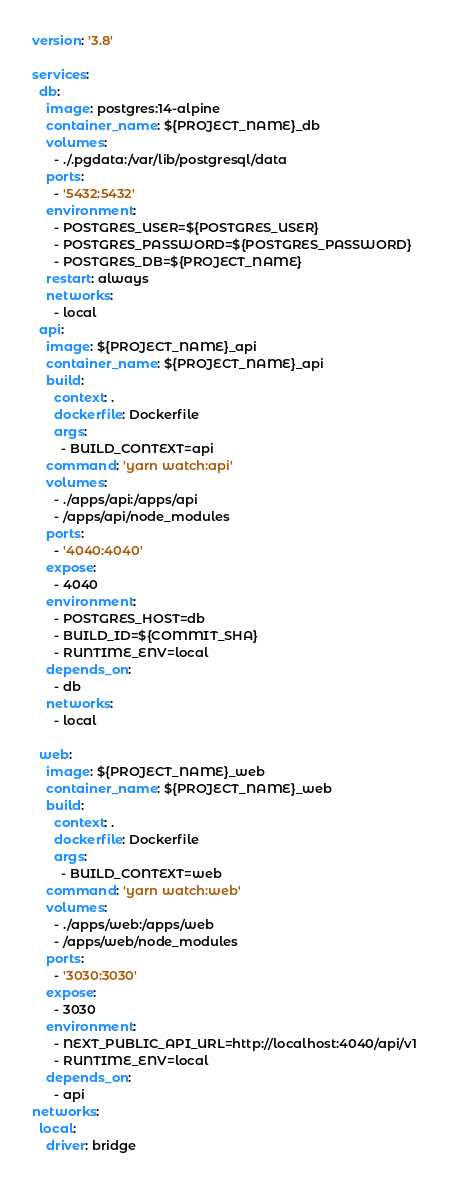Convert code to text. <code><loc_0><loc_0><loc_500><loc_500><_YAML_>version: '3.8'

services:
  db:
    image: postgres:14-alpine
    container_name: ${PROJECT_NAME}_db
    volumes:
      - ./.pgdata:/var/lib/postgresql/data
    ports:
      - '5432:5432'
    environment:
      - POSTGRES_USER=${POSTGRES_USER}
      - POSTGRES_PASSWORD=${POSTGRES_PASSWORD}
      - POSTGRES_DB=${PROJECT_NAME}
    restart: always
    networks:
      - local
  api:
    image: ${PROJECT_NAME}_api
    container_name: ${PROJECT_NAME}_api
    build:
      context: .
      dockerfile: Dockerfile
      args:
        - BUILD_CONTEXT=api
    command: 'yarn watch:api'
    volumes:
      - ./apps/api:/apps/api
      - /apps/api/node_modules
    ports:
      - '4040:4040'
    expose:
      - 4040
    environment:
      - POSTGRES_HOST=db
      - BUILD_ID=${COMMIT_SHA}
      - RUNTIME_ENV=local
    depends_on:
      - db
    networks:
      - local

  web:
    image: ${PROJECT_NAME}_web
    container_name: ${PROJECT_NAME}_web
    build:
      context: .
      dockerfile: Dockerfile
      args:
        - BUILD_CONTEXT=web
    command: 'yarn watch:web'
    volumes:
      - ./apps/web:/apps/web
      - /apps/web/node_modules
    ports:
      - '3030:3030'
    expose:
      - 3030
    environment:
      - NEXT_PUBLIC_API_URL=http://localhost:4040/api/v1
      - RUNTIME_ENV=local
    depends_on:
      - api
networks:
  local:
    driver: bridge
</code> 